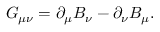Convert formula to latex. <formula><loc_0><loc_0><loc_500><loc_500>G _ { \mu \nu } = \partial _ { \mu } B _ { \nu } - \partial _ { \nu } B _ { \mu } .</formula> 